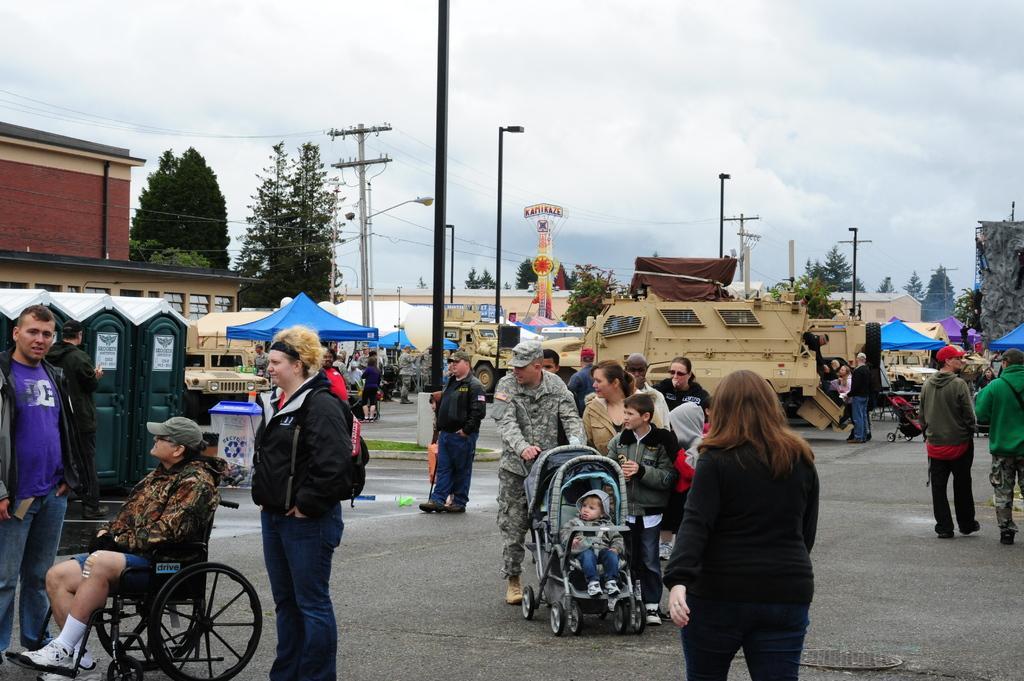Describe this image in one or two sentences. In this picture there is a group men and women with baby prams are walking on the street. Behind there is a brown color military tank and jeeps are parked. In the background we can see some electric poles are trees. 